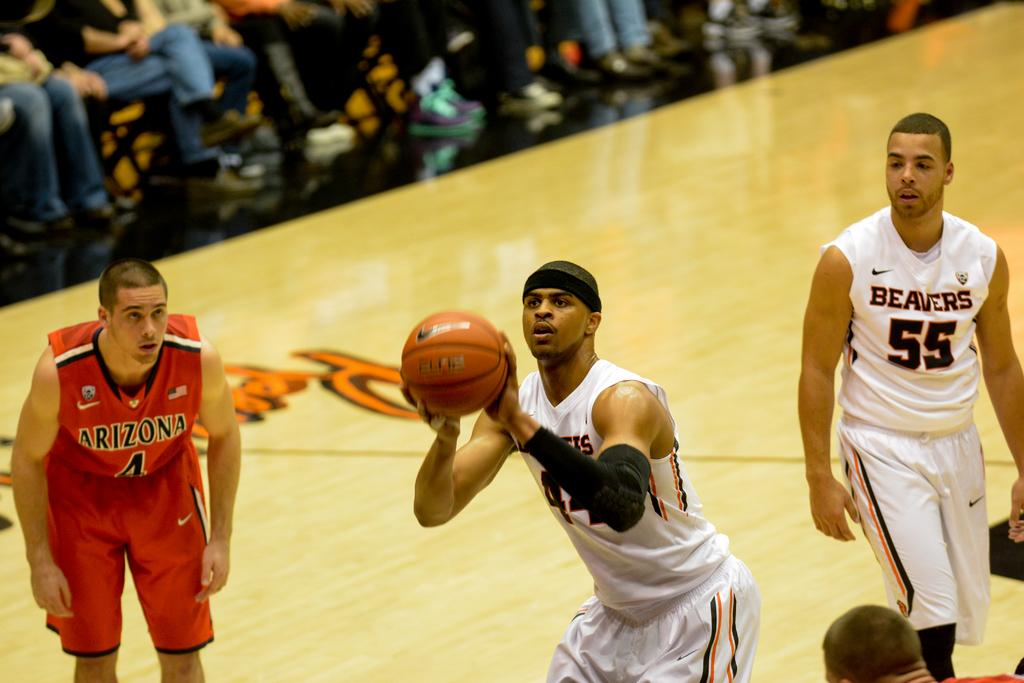<image>
Give a short and clear explanation of the subsequent image. A basketball player for the beavers lines for a free throw against Arizona. 